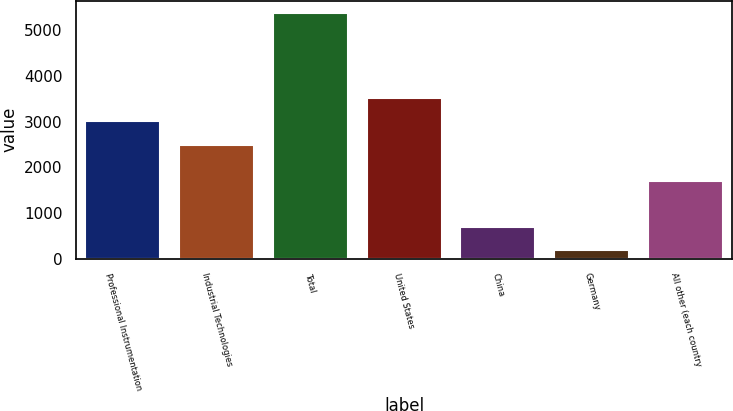<chart> <loc_0><loc_0><loc_500><loc_500><bar_chart><fcel>Professional Instrumentation<fcel>Industrial Technologies<fcel>Total<fcel>United States<fcel>China<fcel>Germany<fcel>All other (each country<nl><fcel>3006.37<fcel>2486.6<fcel>5378.2<fcel>3526.14<fcel>700.27<fcel>180.5<fcel>1710<nl></chart> 